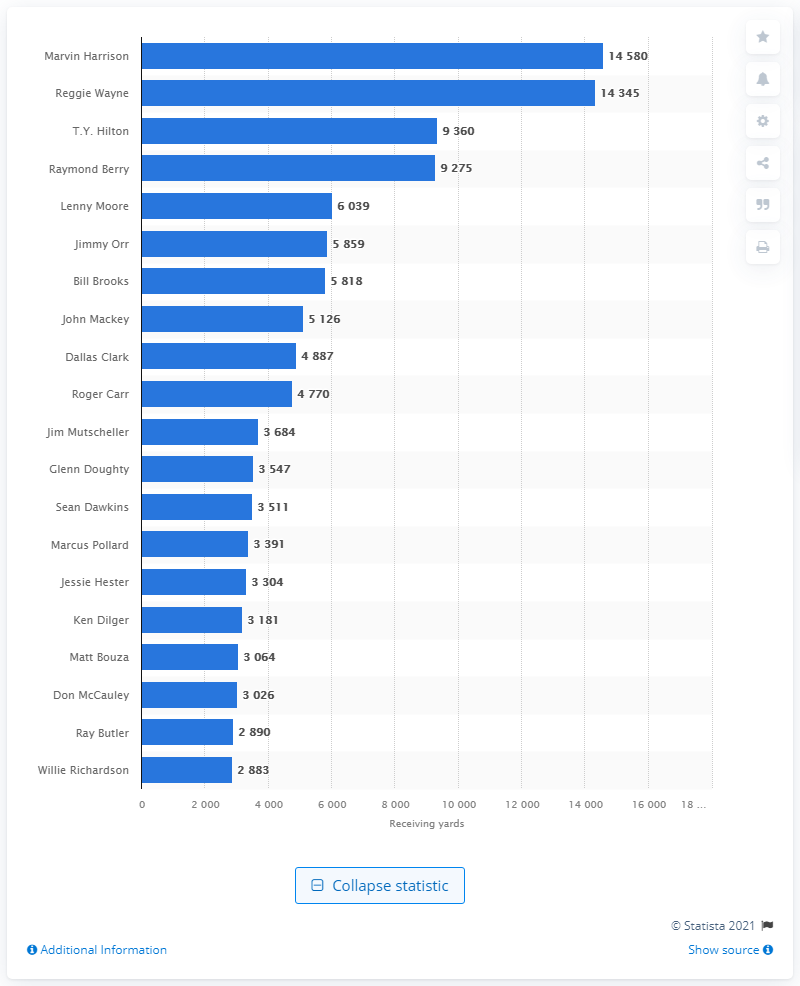Give some essential details in this illustration. Marvin Harrison is the career receiving leader of the Indianapolis Colts. 